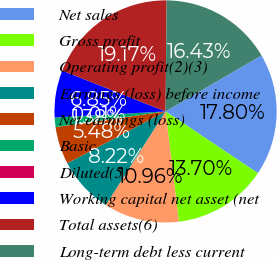Convert chart. <chart><loc_0><loc_0><loc_500><loc_500><pie_chart><fcel>Net sales<fcel>Gross profit<fcel>Operating profit(2)(3)<fcel>Earnings (loss) before income<fcel>Net earnings (loss)<fcel>Basic<fcel>Diluted(5)<fcel>Working capital net asset (net<fcel>Total assets(6)<fcel>Long-term debt less current<nl><fcel>17.8%<fcel>13.7%<fcel>10.96%<fcel>8.22%<fcel>5.48%<fcel>1.38%<fcel>0.01%<fcel>6.85%<fcel>19.17%<fcel>16.43%<nl></chart> 